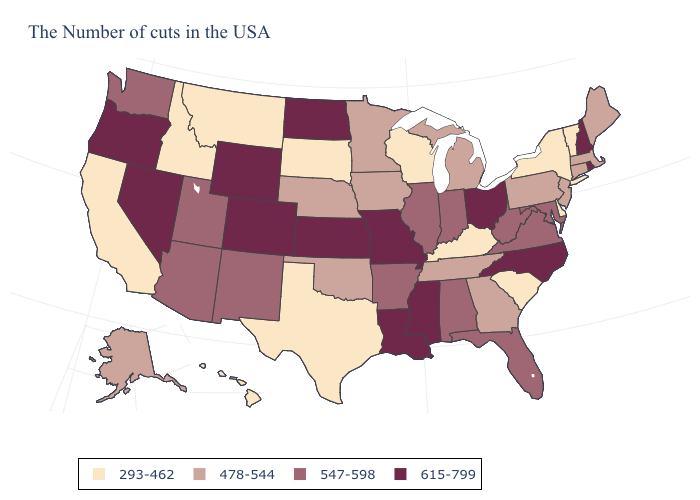Which states have the highest value in the USA?
Write a very short answer. Rhode Island, New Hampshire, North Carolina, Ohio, Mississippi, Louisiana, Missouri, Kansas, North Dakota, Wyoming, Colorado, Nevada, Oregon. What is the value of Vermont?
Concise answer only. 293-462. Does Michigan have the highest value in the MidWest?
Short answer required. No. Among the states that border Nevada , does Utah have the lowest value?
Be succinct. No. What is the highest value in the Northeast ?
Concise answer only. 615-799. Is the legend a continuous bar?
Answer briefly. No. Name the states that have a value in the range 478-544?
Quick response, please. Maine, Massachusetts, Connecticut, New Jersey, Pennsylvania, Georgia, Michigan, Tennessee, Minnesota, Iowa, Nebraska, Oklahoma, Alaska. Name the states that have a value in the range 293-462?
Answer briefly. Vermont, New York, Delaware, South Carolina, Kentucky, Wisconsin, Texas, South Dakota, Montana, Idaho, California, Hawaii. What is the highest value in the USA?
Answer briefly. 615-799. Among the states that border North Carolina , which have the highest value?
Short answer required. Virginia. What is the value of Mississippi?
Write a very short answer. 615-799. Does Massachusetts have the lowest value in the USA?
Answer briefly. No. Name the states that have a value in the range 293-462?
Write a very short answer. Vermont, New York, Delaware, South Carolina, Kentucky, Wisconsin, Texas, South Dakota, Montana, Idaho, California, Hawaii. What is the value of South Carolina?
Quick response, please. 293-462. What is the value of Missouri?
Concise answer only. 615-799. 